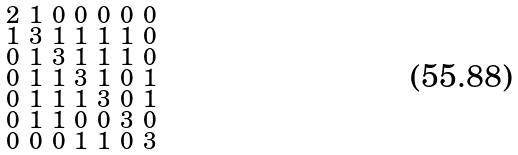<formula> <loc_0><loc_0><loc_500><loc_500>\begin{smallmatrix} 2 & 1 & 0 & 0 & 0 & 0 & 0 \\ 1 & 3 & 1 & 1 & 1 & 1 & 0 \\ 0 & 1 & 3 & 1 & 1 & 1 & 0 \\ 0 & 1 & 1 & 3 & 1 & 0 & 1 \\ 0 & 1 & 1 & 1 & 3 & 0 & 1 \\ 0 & 1 & 1 & 0 & 0 & 3 & 0 \\ 0 & 0 & 0 & 1 & 1 & 0 & 3 \end{smallmatrix}</formula> 